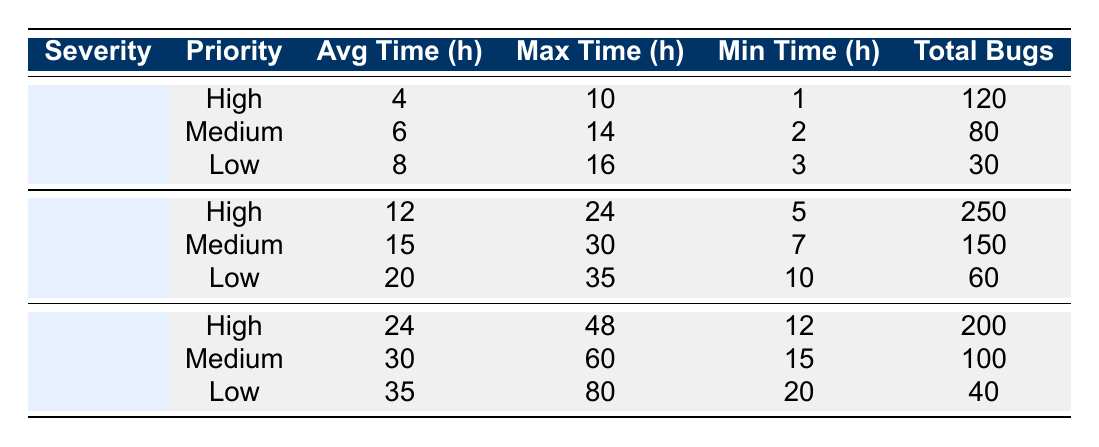What is the average resolution time for critical bugs with high priority? The table shows that for critical bugs with high priority, the average resolution time is clearly stated as 4 hours.
Answer: 4 hours How many total critical bugs were resolved in the medium priority category? From the table, it can be seen that the total bugs resolved under the critical severity with medium priority is 80.
Answer: 80 What is the maximum resolution time for major bugs with low priority? Looking at the table, the maximum resolution time for major bugs with low priority is recorded as 35 hours.
Answer: 35 hours What is the total average resolution time for all minor bugs? To find the total average resolution time for minor bugs, we can compute the average of their individual average resolution times: (24 + 30 + 35) / 3 = 29.67 hours.
Answer: 29.67 hours Did more total critical bugs get resolved than major bugs? The table states that 120 critical bugs were resolved compared to 250 major bugs resolved. Therefore, the statement is false.
Answer: No Which severity-priority combination has the highest total bugs resolved? From the table, the major bugs with high priority have the highest total bugs resolved, which is 250.
Answer: Major High What is the difference in average resolution time between minor high priority and critical high priority bugs? The average resolution time for minor high priority bugs is 24 hours and for critical high priority is 4 hours. The difference is 24 - 4 = 20 hours.
Answer: 20 hours Is the minimum resolution time for critical low priority bugs less than the average for major medium priority? Checking the table, the minimum for critical low is 3 hours and the average for major medium is 15 hours. Since 3 is less than 15, the statement is true.
Answer: Yes What is the range of resolution times for major bugs with high priority? The table shows that for major bugs with high priority, the maximum resolution time is 24 hours and the minimum is 5 hours. Thus, the range is 24 - 5 = 19 hours.
Answer: 19 hours 